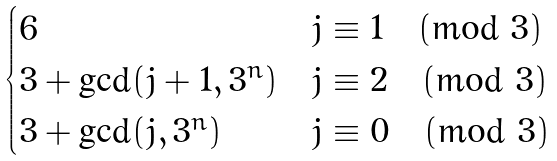Convert formula to latex. <formula><loc_0><loc_0><loc_500><loc_500>\begin{cases} 6 & j \equiv 1 \pmod { 3 } \\ 3 + \gcd ( j + 1 , 3 ^ { n } ) & j \equiv 2 \pmod { 3 } \\ 3 + \gcd ( j , 3 ^ { n } ) & j \equiv 0 \pmod { 3 } \end{cases}</formula> 